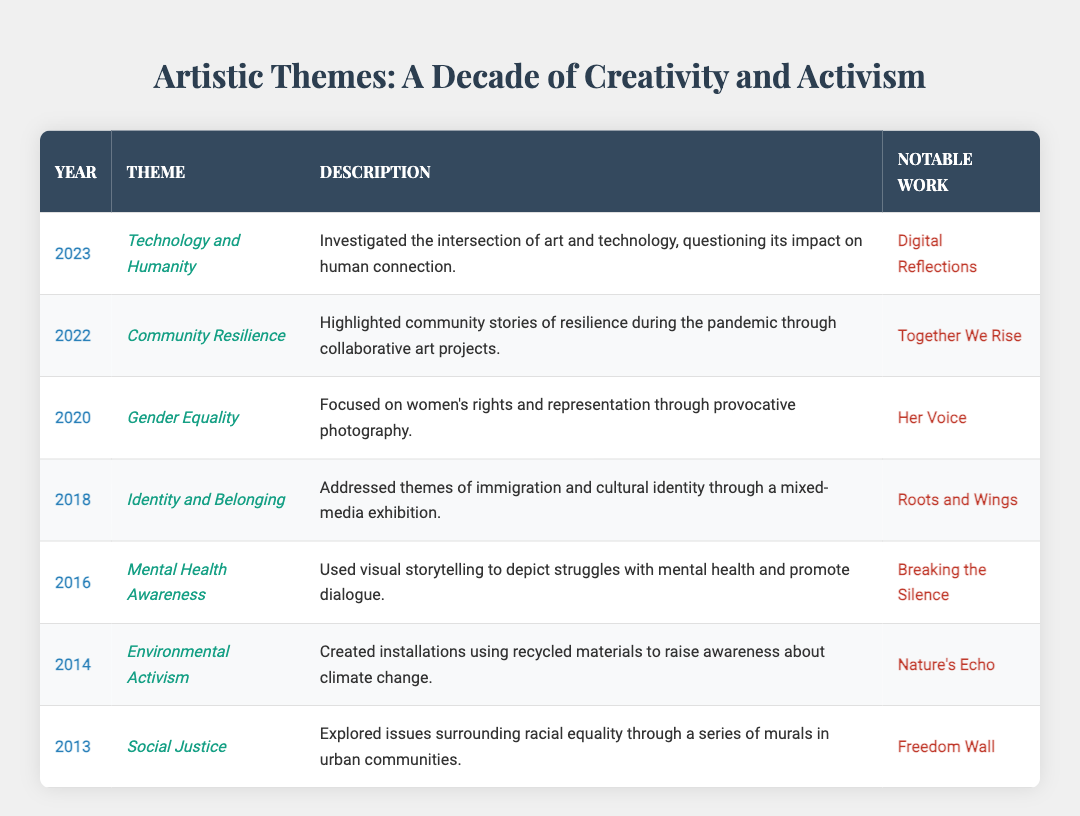What was the notable work associated with the theme of Gender Equality? According to the table, the theme of Gender Equality in 2020 is associated with the notable work titled "Her Voice."
Answer: Her Voice In which year did the artist explore themes of Identity and Belonging? The table indicates that the theme of Identity and Belonging was explored in 2018.
Answer: 2018 Is it true that the artist focused on Social Justice before diving into Environmental Activism? Yes, the table shows that the artist explored Social Justice in 2013 and then focused on Environmental Activism in 2014.
Answer: Yes How many distinct themes did the artist address between 2013 and 2023? By counting each unique theme mentioned in the table from 2013 to 2023, there are a total of 7 distinct themes.
Answer: 7 Which artistic theme had the description involving the intersection of art and technology? The theme that investigates the intersection of art and technology is "Technology and Humanity," which was explored in 2023.
Answer: Technology and Humanity What is the difference in years between the themes of Mental Health Awareness and Community Resilience? Mental Health Awareness was explored in 2016 and Community Resilience in 2022. The difference in years is 2022 - 2016 = 6 years.
Answer: 6 years Which theme is linked to the notable work "Breaking the Silence"? The table specifies that the theme linked to the notable work "Breaking the Silence" is Mental Health Awareness, which was highlighted in 2016.
Answer: Mental Health Awareness Was there a year when the artist addressed both Environmental Activism and Community Resilience? No, the table indicates that Environmental Activism was addressed in 2014 and Community Resilience in 2022, with no overlap.
Answer: No List the themes explored in chronological order from earliest to latest. The themes in chronological order are: Social Justice, Environmental Activism, Mental Health Awareness, Identity and Belonging, Gender Equality, Community Resilience, Technology and Humanity.
Answer: Social Justice, Environmental Activism, Mental Health Awareness, Identity and Belonging, Gender Equality, Community Resilience, Technology and Humanity 